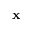<formula> <loc_0><loc_0><loc_500><loc_500>x</formula> 